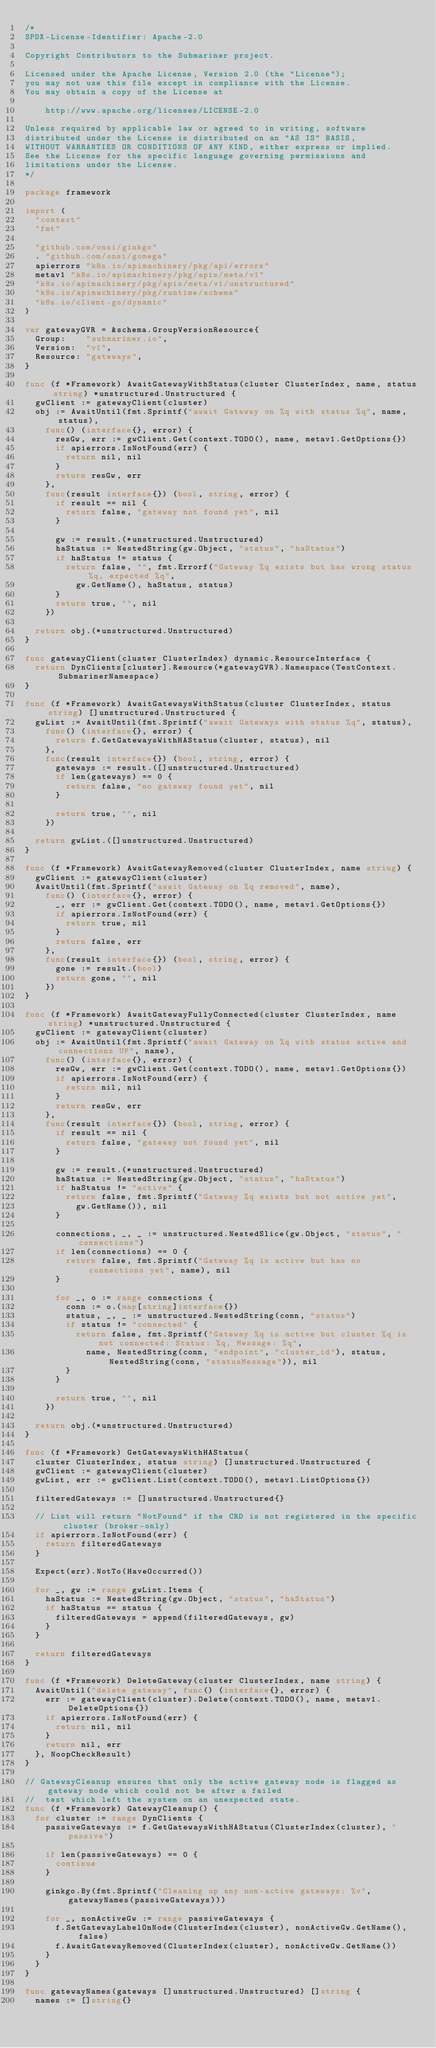<code> <loc_0><loc_0><loc_500><loc_500><_Go_>/*
SPDX-License-Identifier: Apache-2.0

Copyright Contributors to the Submariner project.

Licensed under the Apache License, Version 2.0 (the "License");
you may not use this file except in compliance with the License.
You may obtain a copy of the License at

    http://www.apache.org/licenses/LICENSE-2.0

Unless required by applicable law or agreed to in writing, software
distributed under the License is distributed on an "AS IS" BASIS,
WITHOUT WARRANTIES OR CONDITIONS OF ANY KIND, either express or implied.
See the License for the specific language governing permissions and
limitations under the License.
*/

package framework

import (
	"context"
	"fmt"

	"github.com/onsi/ginkgo"
	. "github.com/onsi/gomega"
	apierrors "k8s.io/apimachinery/pkg/api/errors"
	metav1 "k8s.io/apimachinery/pkg/apis/meta/v1"
	"k8s.io/apimachinery/pkg/apis/meta/v1/unstructured"
	"k8s.io/apimachinery/pkg/runtime/schema"
	"k8s.io/client-go/dynamic"
)

var gatewayGVR = &schema.GroupVersionResource{
	Group:    "submariner.io",
	Version:  "v1",
	Resource: "gateways",
}

func (f *Framework) AwaitGatewayWithStatus(cluster ClusterIndex, name, status string) *unstructured.Unstructured {
	gwClient := gatewayClient(cluster)
	obj := AwaitUntil(fmt.Sprintf("await Gateway on %q with status %q", name, status),
		func() (interface{}, error) {
			resGw, err := gwClient.Get(context.TODO(), name, metav1.GetOptions{})
			if apierrors.IsNotFound(err) {
				return nil, nil
			}
			return resGw, err
		},
		func(result interface{}) (bool, string, error) {
			if result == nil {
				return false, "gateway not found yet", nil
			}

			gw := result.(*unstructured.Unstructured)
			haStatus := NestedString(gw.Object, "status", "haStatus")
			if haStatus != status {
				return false, "", fmt.Errorf("Gateway %q exists but has wrong status %q, expected %q",
					gw.GetName(), haStatus, status)
			}
			return true, "", nil
		})

	return obj.(*unstructured.Unstructured)
}

func gatewayClient(cluster ClusterIndex) dynamic.ResourceInterface {
	return DynClients[cluster].Resource(*gatewayGVR).Namespace(TestContext.SubmarinerNamespace)
}

func (f *Framework) AwaitGatewaysWithStatus(cluster ClusterIndex, status string) []unstructured.Unstructured {
	gwList := AwaitUntil(fmt.Sprintf("await Gateways with status %q", status),
		func() (interface{}, error) {
			return f.GetGatewaysWithHAStatus(cluster, status), nil
		},
		func(result interface{}) (bool, string, error) {
			gateways := result.([]unstructured.Unstructured)
			if len(gateways) == 0 {
				return false, "no gateway found yet", nil
			}

			return true, "", nil
		})

	return gwList.([]unstructured.Unstructured)
}

func (f *Framework) AwaitGatewayRemoved(cluster ClusterIndex, name string) {
	gwClient := gatewayClient(cluster)
	AwaitUntil(fmt.Sprintf("await Gateway on %q removed", name),
		func() (interface{}, error) {
			_, err := gwClient.Get(context.TODO(), name, metav1.GetOptions{})
			if apierrors.IsNotFound(err) {
				return true, nil
			}
			return false, err
		},
		func(result interface{}) (bool, string, error) {
			gone := result.(bool)
			return gone, "", nil
		})
}

func (f *Framework) AwaitGatewayFullyConnected(cluster ClusterIndex, name string) *unstructured.Unstructured {
	gwClient := gatewayClient(cluster)
	obj := AwaitUntil(fmt.Sprintf("await Gateway on %q with status active and connections UP", name),
		func() (interface{}, error) {
			resGw, err := gwClient.Get(context.TODO(), name, metav1.GetOptions{})
			if apierrors.IsNotFound(err) {
				return nil, nil
			}
			return resGw, err
		},
		func(result interface{}) (bool, string, error) {
			if result == nil {
				return false, "gateway not found yet", nil
			}

			gw := result.(*unstructured.Unstructured)
			haStatus := NestedString(gw.Object, "status", "haStatus")
			if haStatus != "active" {
				return false, fmt.Sprintf("Gateway %q exists but not active yet",
					gw.GetName()), nil
			}

			connections, _, _ := unstructured.NestedSlice(gw.Object, "status", "connections")
			if len(connections) == 0 {
				return false, fmt.Sprintf("Gateway %q is active but has no connections yet", name), nil
			}

			for _, o := range connections {
				conn := o.(map[string]interface{})
				status, _, _ := unstructured.NestedString(conn, "status")
				if status != "connected" {
					return false, fmt.Sprintf("Gateway %q is active but cluster %q is not connected: Status: %q, Message: %q",
						name, NestedString(conn, "endpoint", "cluster_id"), status, NestedString(conn, "statusMessage")), nil
				}
			}

			return true, "", nil
		})

	return obj.(*unstructured.Unstructured)
}

func (f *Framework) GetGatewaysWithHAStatus(
	cluster ClusterIndex, status string) []unstructured.Unstructured {
	gwClient := gatewayClient(cluster)
	gwList, err := gwClient.List(context.TODO(), metav1.ListOptions{})

	filteredGateways := []unstructured.Unstructured{}

	// List will return "NotFound" if the CRD is not registered in the specific cluster (broker-only)
	if apierrors.IsNotFound(err) {
		return filteredGateways
	}

	Expect(err).NotTo(HaveOccurred())

	for _, gw := range gwList.Items {
		haStatus := NestedString(gw.Object, "status", "haStatus")
		if haStatus == status {
			filteredGateways = append(filteredGateways, gw)
		}
	}

	return filteredGateways
}

func (f *Framework) DeleteGateway(cluster ClusterIndex, name string) {
	AwaitUntil("delete gateway", func() (interface{}, error) {
		err := gatewayClient(cluster).Delete(context.TODO(), name, metav1.DeleteOptions{})
		if apierrors.IsNotFound(err) {
			return nil, nil
		}
		return nil, err
	}, NoopCheckResult)
}

// GatewayCleanup ensures that only the active gateway node is flagged as gateway node which could not be after a failed
//  test which left the system on an unexpected state.
func (f *Framework) GatewayCleanup() {
	for cluster := range DynClients {
		passiveGateways := f.GetGatewaysWithHAStatus(ClusterIndex(cluster), "passive")

		if len(passiveGateways) == 0 {
			continue
		}

		ginkgo.By(fmt.Sprintf("Cleaning up any non-active gateways: %v", gatewayNames(passiveGateways)))

		for _, nonActiveGw := range passiveGateways {
			f.SetGatewayLabelOnNode(ClusterIndex(cluster), nonActiveGw.GetName(), false)
			f.AwaitGatewayRemoved(ClusterIndex(cluster), nonActiveGw.GetName())
		}
	}
}

func gatewayNames(gateways []unstructured.Unstructured) []string {
	names := []string{}</code> 